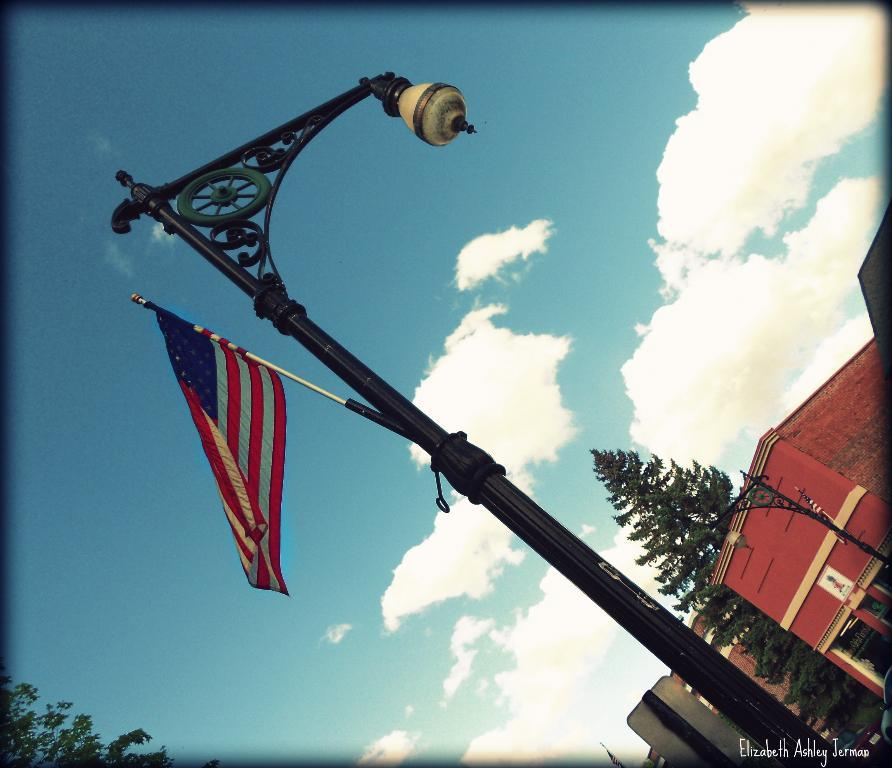What is the main object in the center of the image? There is a pole in the center of the image. What is attached to the pole? A flag is placed on the pole. What can be seen in the background of the image? There are trees, at least one building, and another pole in the background of the image. What part of the natural environment is visible in the image? The sky is visible in the background of the image. What type of soup is being served in the image? There is no soup present in the image; it features a pole with a flag and a background with trees, buildings, and other poles. 